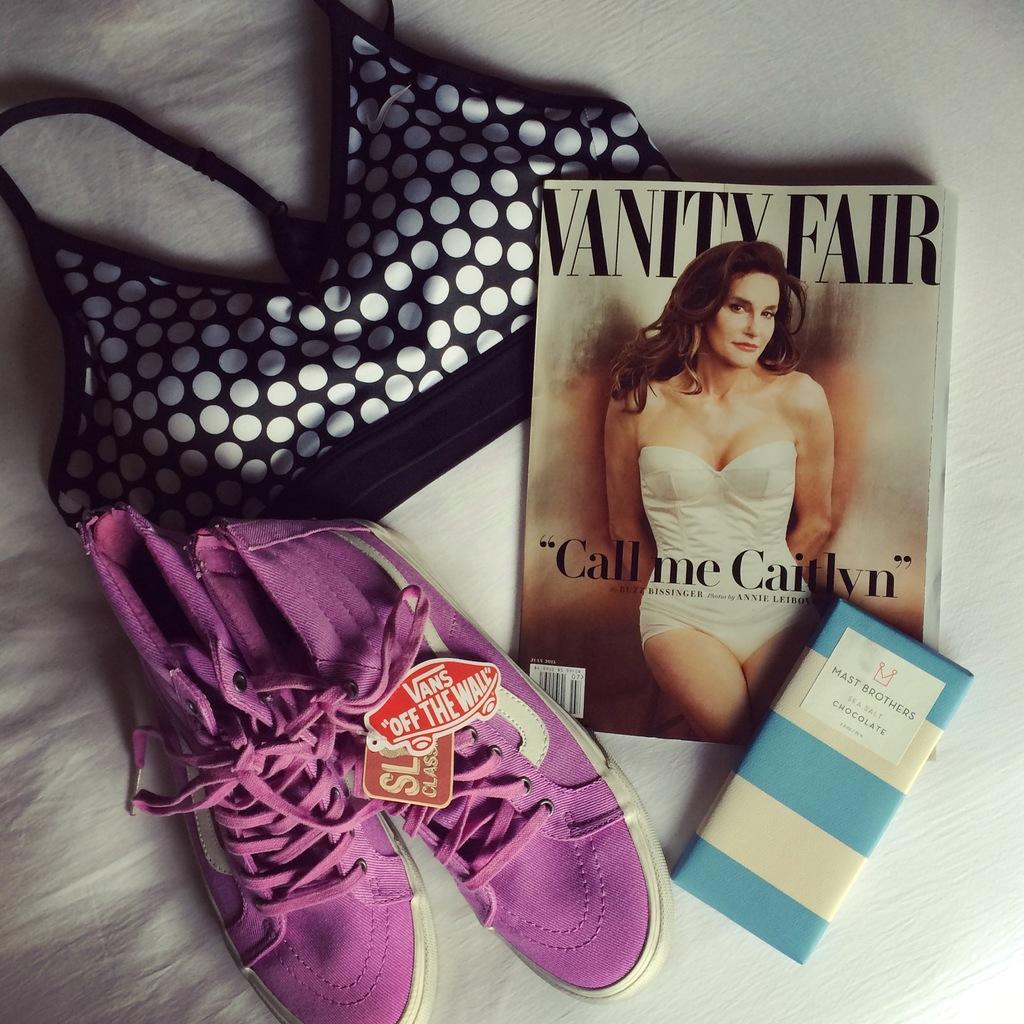Please provide a concise description of this image. On this white surface we can see shoes, book, chocolate, and cloth. 